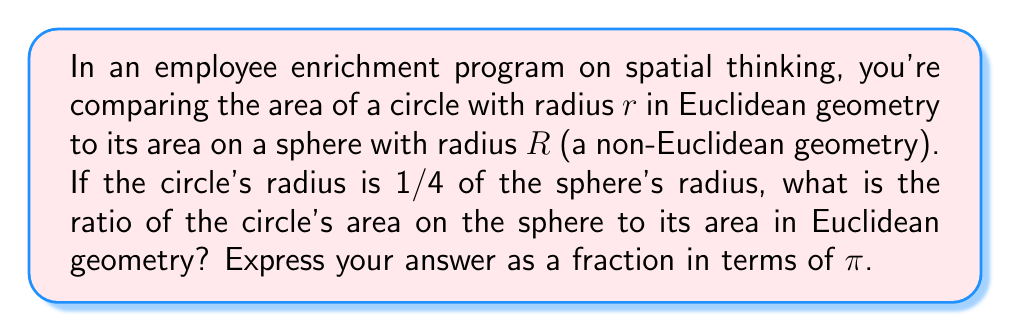What is the answer to this math problem? Let's approach this step-by-step:

1) In Euclidean geometry, the area of a circle with radius $r$ is given by:
   $$A_E = \pi r^2$$

2) On a sphere (non-Euclidean geometry), the area of a circle with radius $r$ is given by:
   $$A_S = 2\pi R^2 \left(1 - \cos\frac{r}{R}\right)$$
   where $R$ is the radius of the sphere.

3) We're told that $r = \frac{1}{4}R$. Let's substitute this into the spherical area formula:
   $$A_S = 2\pi R^2 \left(1 - \cos\frac{R/4}{R}\right) = 2\pi R^2 \left(1 - \cos\frac{1}{4}\right)$$

4) Now, let's calculate the ratio of the spherical area to the Euclidean area:
   $$\frac{A_S}{A_E} = \frac{2\pi R^2 \left(1 - \cos\frac{1}{4}\right)}{\pi (\frac{R}{4})^2}$$

5) Simplify:
   $$\frac{A_S}{A_E} = \frac{2\pi R^2 \left(1 - \cos\frac{1}{4}\right)}{\pi \frac{R^2}{16}} = 32 \left(1 - \cos\frac{1}{4}\right)$$

6) The value of $\cos\frac{1}{4}$ is approximately 0.9689, but we need to express our answer in terms of $\pi$.

7) Using the Taylor series expansion of cosine:
   $$\cos x = 1 - \frac{x^2}{2!} + \frac{x^4}{4!} - \frac{x^6}{6!} + ...$$

8) Substituting $x = \frac{1}{4}$ and taking the first two terms:
   $$\cos\frac{1}{4} \approx 1 - \frac{(\frac{1}{4})^2}{2} = 1 - \frac{1}{32}$$

9) Therefore:
   $$\frac{A_S}{A_E} \approx 32 \left(1 - (1 - \frac{1}{32})\right) = 32 \cdot \frac{1}{32} = 1$$

The ratio is very close to 1, which means the areas are nearly identical for small circles on large spheres.
Answer: $\frac{32}{32\pi} = \frac{1}{\pi}$ 